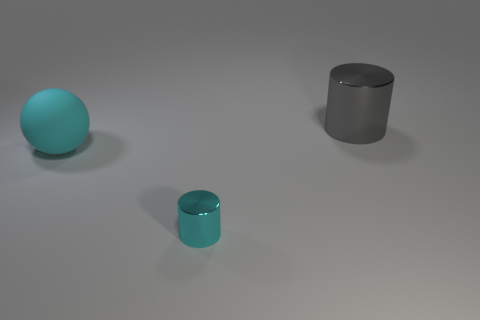Add 1 small cylinders. How many objects exist? 4 Subtract all cylinders. How many objects are left? 1 Subtract all metal cylinders. Subtract all big blue metallic blocks. How many objects are left? 1 Add 3 small things. How many small things are left? 4 Add 3 large cyan metallic things. How many large cyan metallic things exist? 3 Subtract 0 green spheres. How many objects are left? 3 